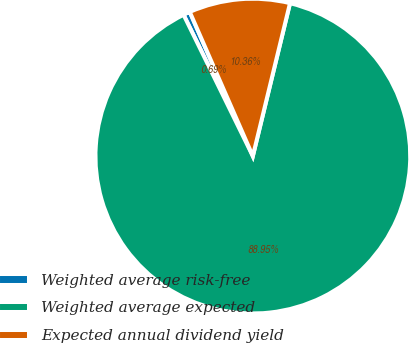Convert chart to OTSL. <chart><loc_0><loc_0><loc_500><loc_500><pie_chart><fcel>Weighted average risk-free<fcel>Weighted average expected<fcel>Expected annual dividend yield<nl><fcel>0.69%<fcel>88.95%<fcel>10.36%<nl></chart> 